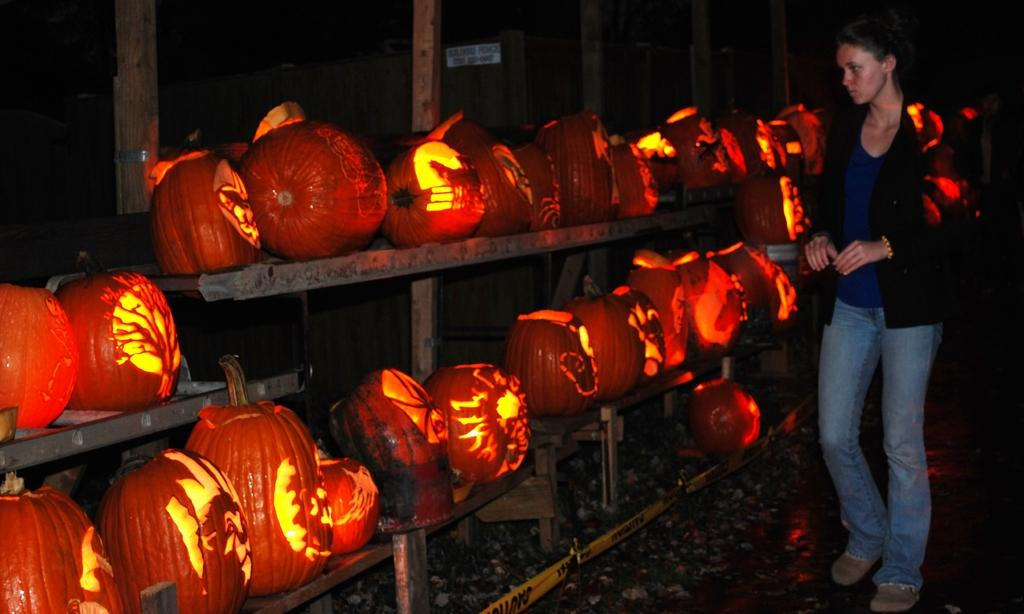What is the main subject of the image? There is a woman standing in the image. What objects can be seen on the left side of the image? There are pumpkins on the left side of the image. How would you describe the overall lighting in the image? The background of the image is dark. What type of patch is being sewn by the carpenter in the image? There is no carpenter or patch present in the image. What ingredients are used to make the stew in the image? There is no stew present in the image. 